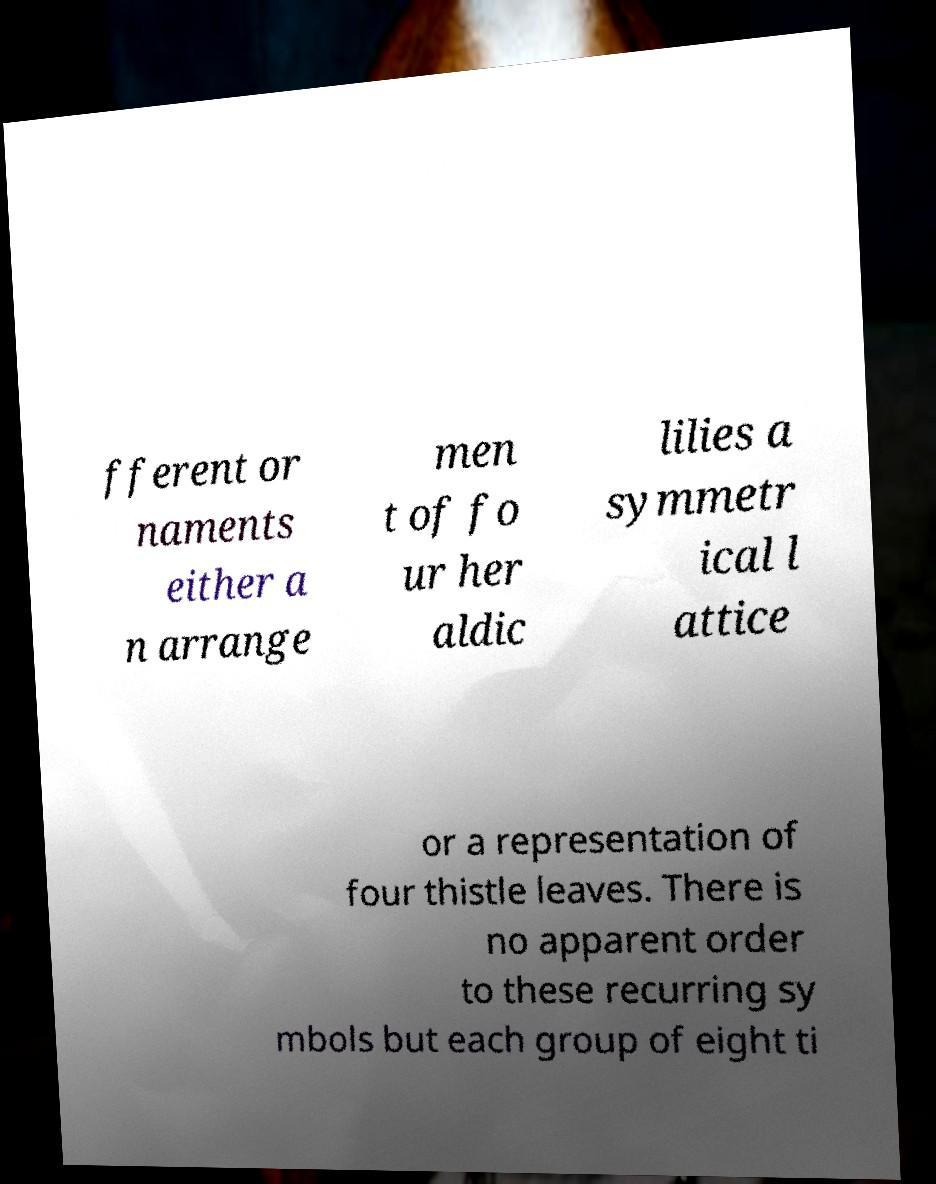Please identify and transcribe the text found in this image. fferent or naments either a n arrange men t of fo ur her aldic lilies a symmetr ical l attice or a representation of four thistle leaves. There is no apparent order to these recurring sy mbols but each group of eight ti 